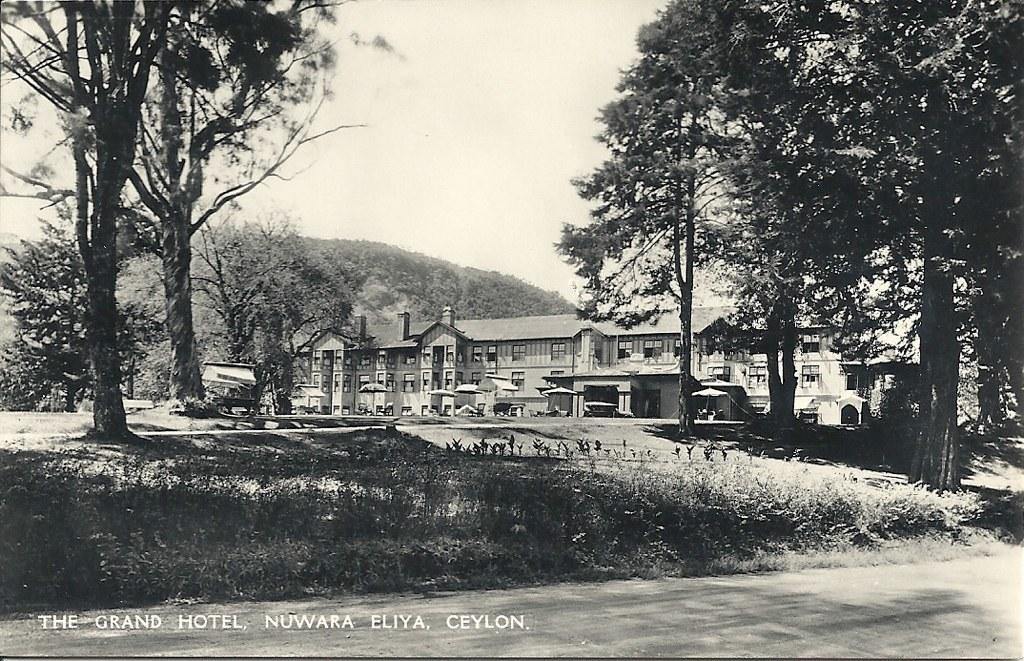What type of natural elements can be seen in the image? There are trees and plants in the image. What type of man-made structures are visible in the image? There are buildings in the image. What part of the natural environment is visible in the image? The sky is visible in the image. What is the color scheme of the image? The image is black and white in color. Is there any additional marking on the image? Yes, there is a watermark on the image. What country is depicted in the image? The image does not depict a specific country; it features trees, plants, buildings, and the sky. What force is being applied to the trees in the image? There is no force being applied to the trees in the image; they are stationary. 